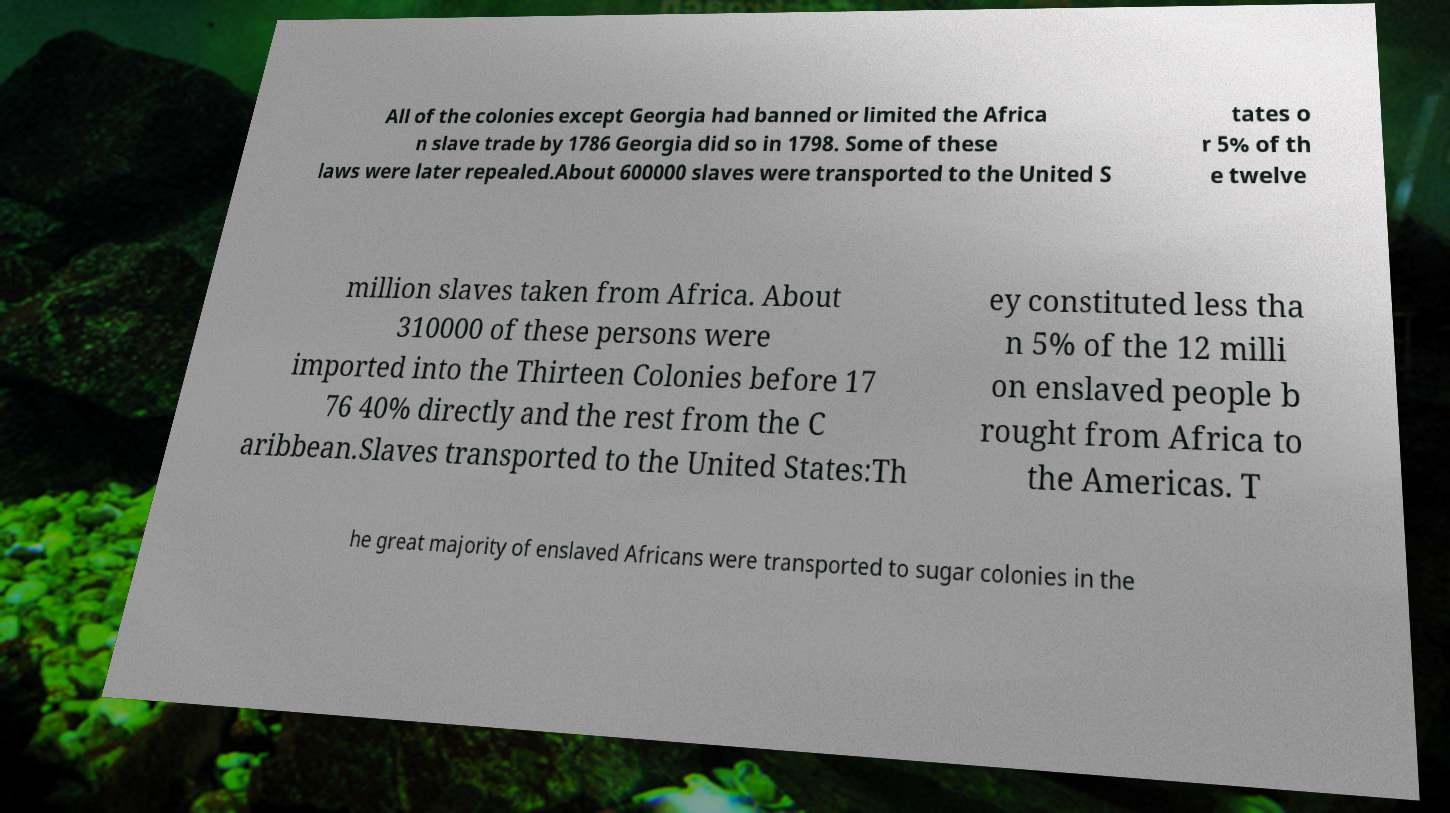Could you assist in decoding the text presented in this image and type it out clearly? All of the colonies except Georgia had banned or limited the Africa n slave trade by 1786 Georgia did so in 1798. Some of these laws were later repealed.About 600000 slaves were transported to the United S tates o r 5% of th e twelve million slaves taken from Africa. About 310000 of these persons were imported into the Thirteen Colonies before 17 76 40% directly and the rest from the C aribbean.Slaves transported to the United States:Th ey constituted less tha n 5% of the 12 milli on enslaved people b rought from Africa to the Americas. T he great majority of enslaved Africans were transported to sugar colonies in the 